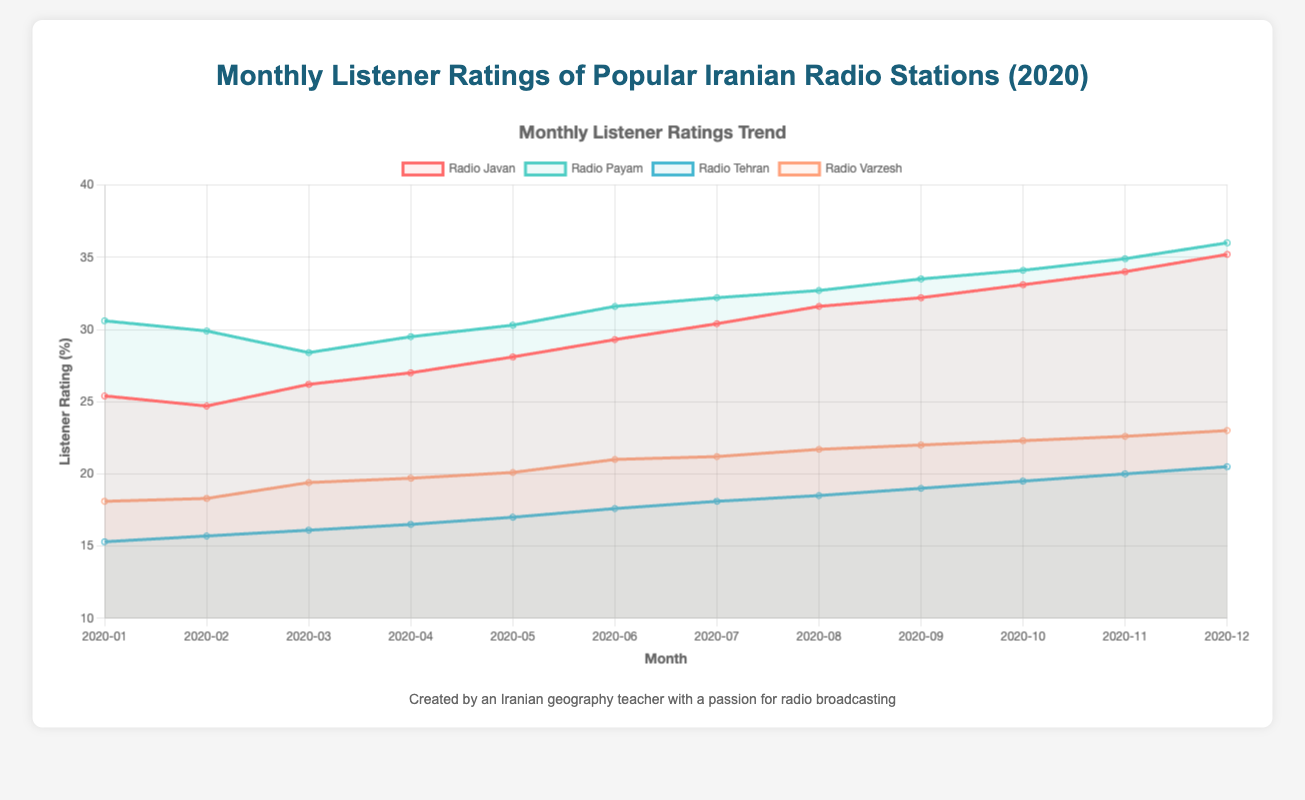Which radio station had the highest listener rating in December 2020? The figure shows the listener ratings for multiple radio stations over the months. In December 2020, Radio Payam had the highest rating at 36.0%.
Answer: Radio Payam How did the listener ratings for Radio Javan change from January to December 2020? By examining the line graph, it is clear that the ratings for Radio Javan increased steadily each month, starting from 25.4% in January and reaching 35.2% in December.
Answer: Increased from 25.4% to 35.2% Which radio station had a consistently increasing trend throughout 2020? Observing the data lines on the graph, Radio Javan shows a consistent upward trajectory in its listener ratings data over each month of 2020.
Answer: Radio Javan What is the difference in listener ratings between Radio Payam and Radio Tehran in July 2020? The figure indicates that in July 2020, Radio Payam had a rating of 32.2% and Radio Tehran had a rating of 18.1%. The difference is 32.2% - 18.1% = 14.1%.
Answer: 14.1% Which month had the highest listener rating for Radio Varzesh and what was the rating? By checking the points on the line graph for Radio Varzesh, it had the highest rating in December 2020 with 23.0%.
Answer: December 2020, 23.0% How did the ratings of Radio Payam compare to those of Radio Javan in September 2020? In September 2020, the ratings for Radio Payam were 33.5%, while Radio Javan had a rating of 32.2%. Thus, Radio Payam had a higher rating than Radio Javan by 1.3%.
Answer: Radio Payam was higher by 1.3% What was the overall trend for Radio Tehran in 2020? The line corresponding to Radio Tehran shows a gradual increase in listener ratings over the months, starting from 15.3% in January to 20.5% in December.
Answer: Gradually increasing Compare the ratings of Radio Varzesh and Radio Tehran in February 2020. Which one was higher and by how much? In February 2020, Radio Varzesh had a rating of 18.3%, compared to Radio Tehran, which had a rating of 15.7%. Radio Varzesh was higher by 2.6%.
Answer: Radio Varzesh by 2.6% What's the average listener rating for Radio Payam over the year 2020? Adding the monthly ratings for Radio Payam: 30.6, 29.9, 28.4, 29.5, 30.3, 31.6, 32.2, 32.7, 33.5, 34.1, 34.9, and 36.0 gives a total of 374.7. Dividing this by 12 months: 374.7/12 ≈ 31.2%.
Answer: 31.2% 